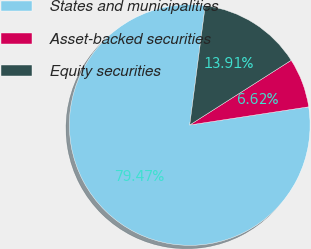Convert chart. <chart><loc_0><loc_0><loc_500><loc_500><pie_chart><fcel>States and municipalities<fcel>Asset-backed securities<fcel>Equity securities<nl><fcel>79.47%<fcel>6.62%<fcel>13.91%<nl></chart> 